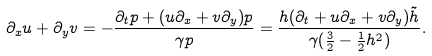Convert formula to latex. <formula><loc_0><loc_0><loc_500><loc_500>\partial _ { x } u + \partial _ { y } v = - \frac { \partial _ { t } p + ( u \partial _ { x } + v \partial _ { y } ) p } { \gamma p } = \frac { h ( \partial _ { t } + u \partial _ { x } + v \partial _ { y } ) \tilde { h } } { \gamma ( \frac { 3 } { 2 } - \frac { 1 } { 2 } h ^ { 2 } ) } .</formula> 